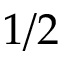<formula> <loc_0><loc_0><loc_500><loc_500>1 / 2</formula> 